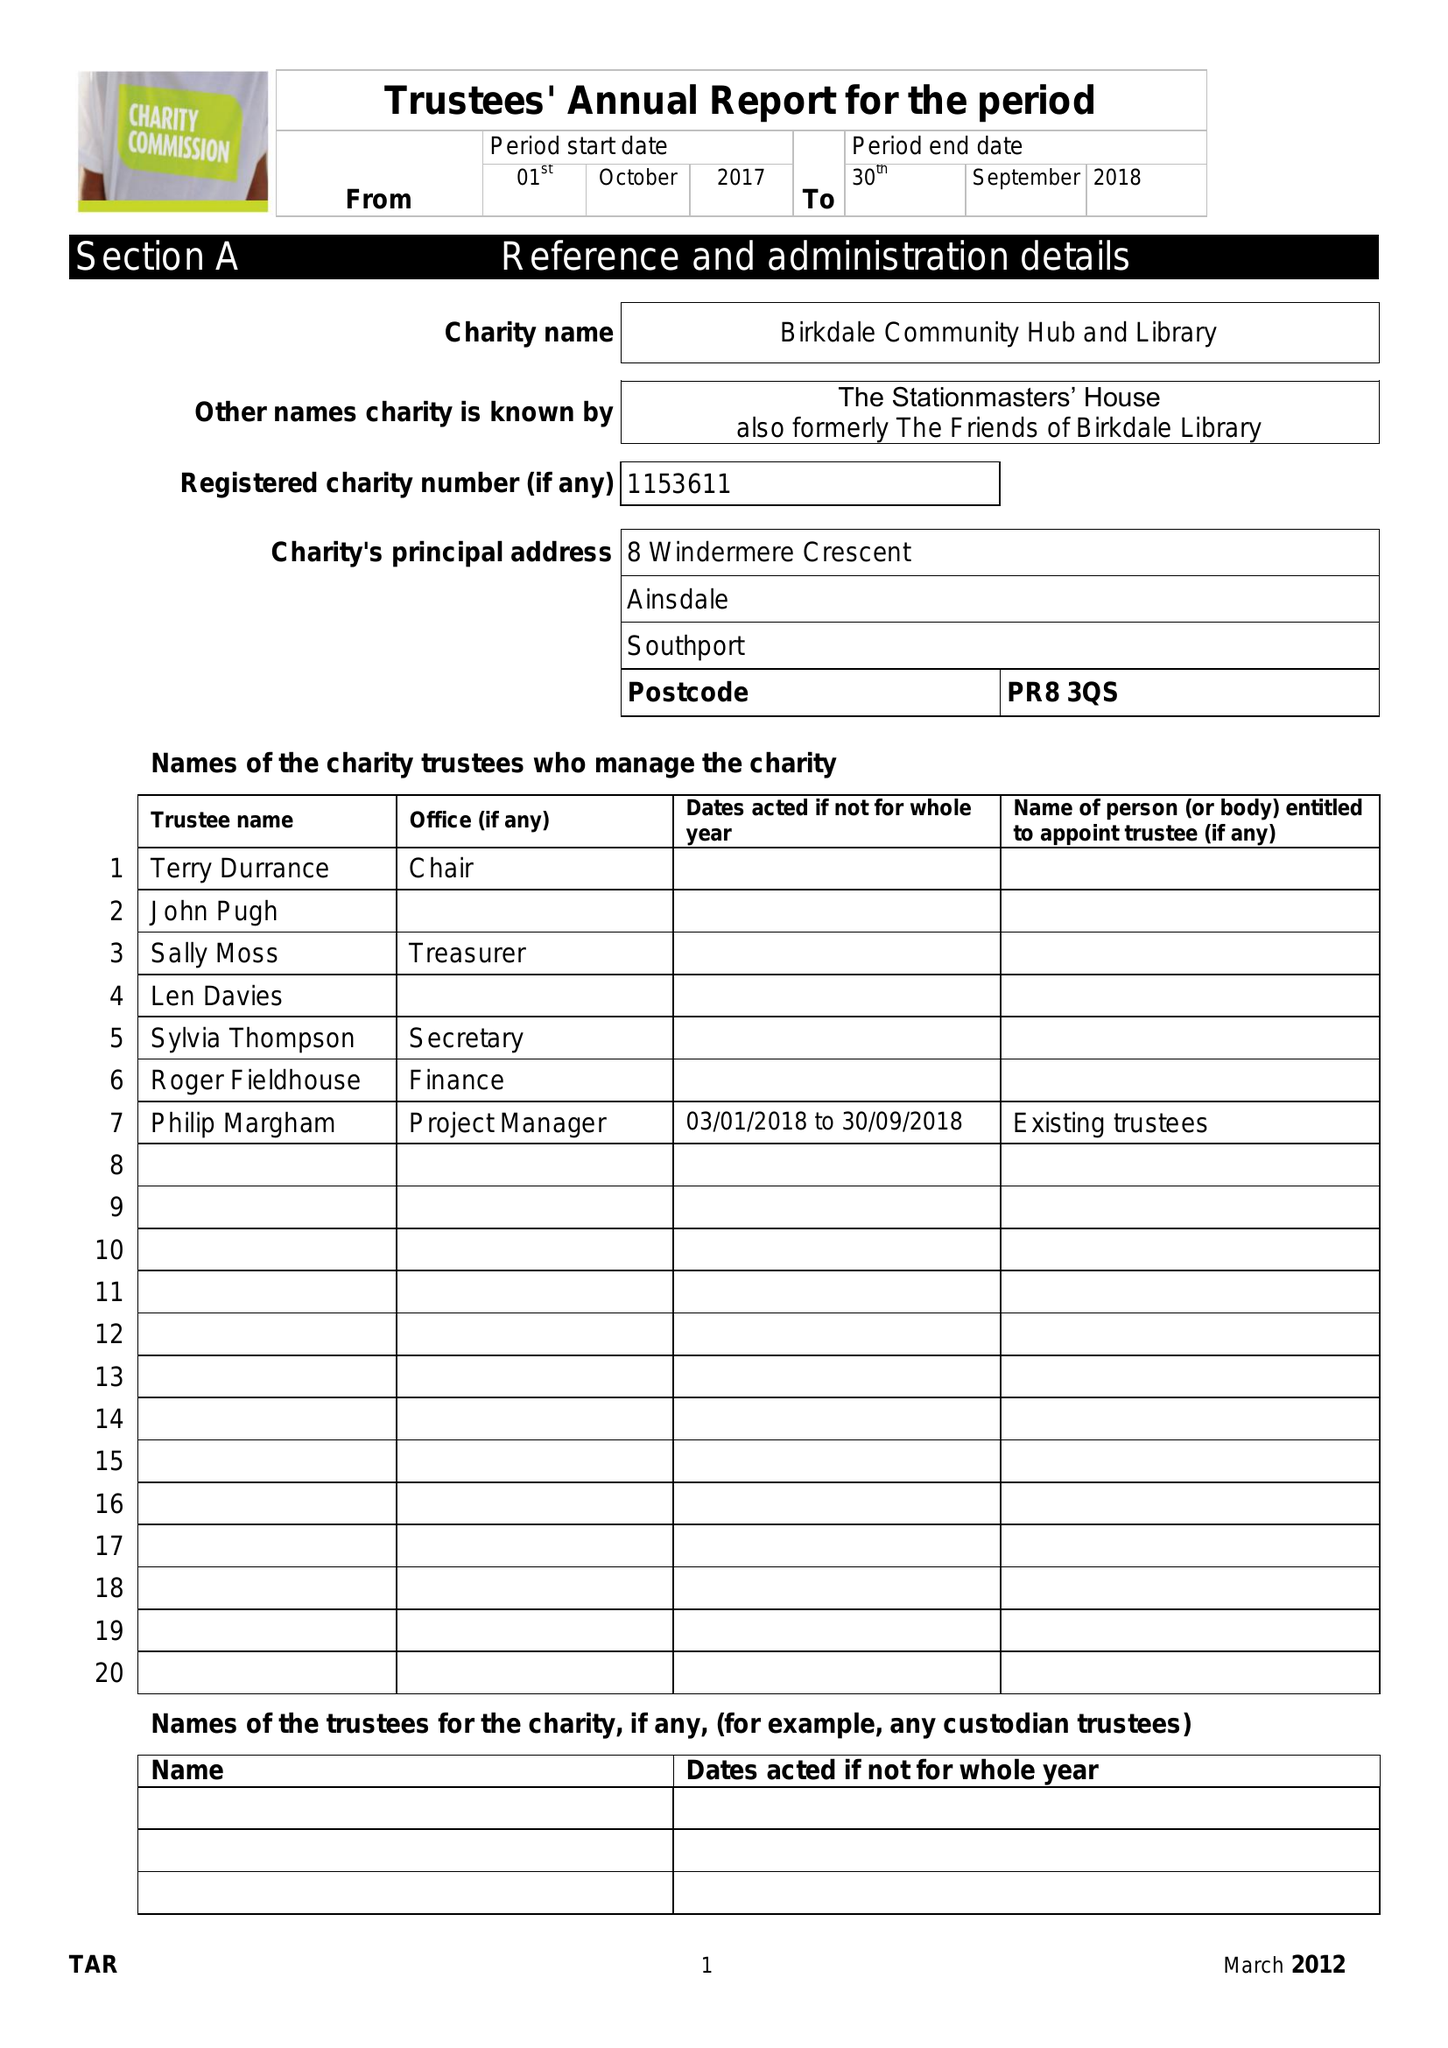What is the value for the income_annually_in_british_pounds?
Answer the question using a single word or phrase. 15468.00 